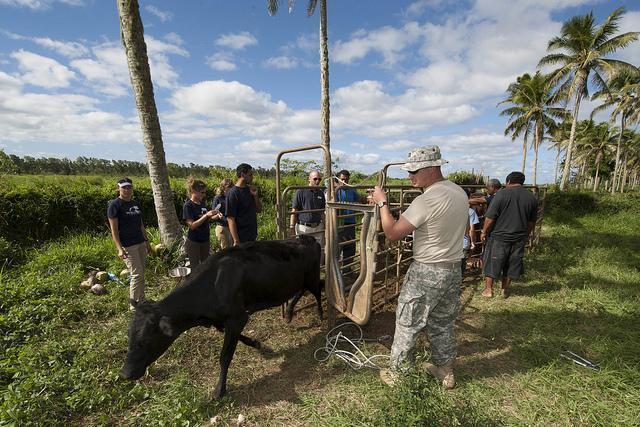How many people are in the photo?
Give a very brief answer. 4. 